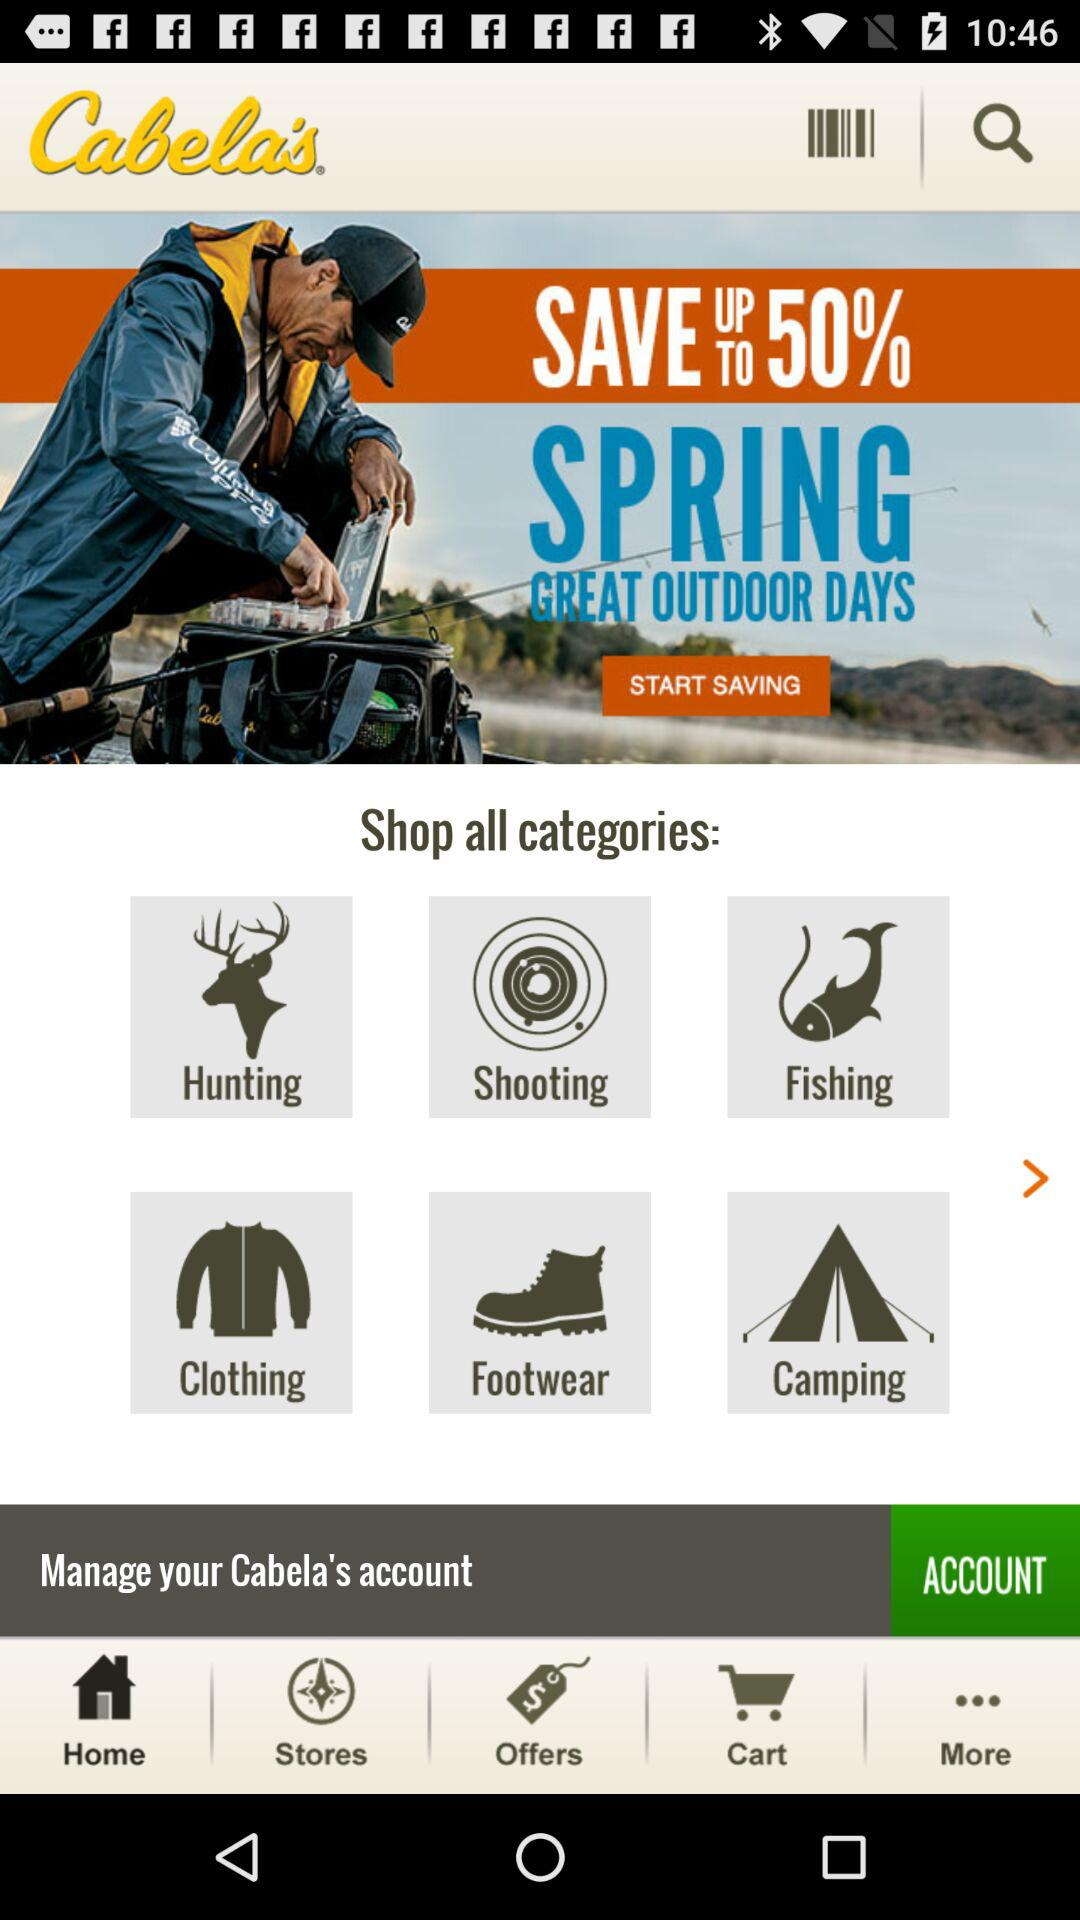What is the name of the application? The name of the application is "Cabela's". 